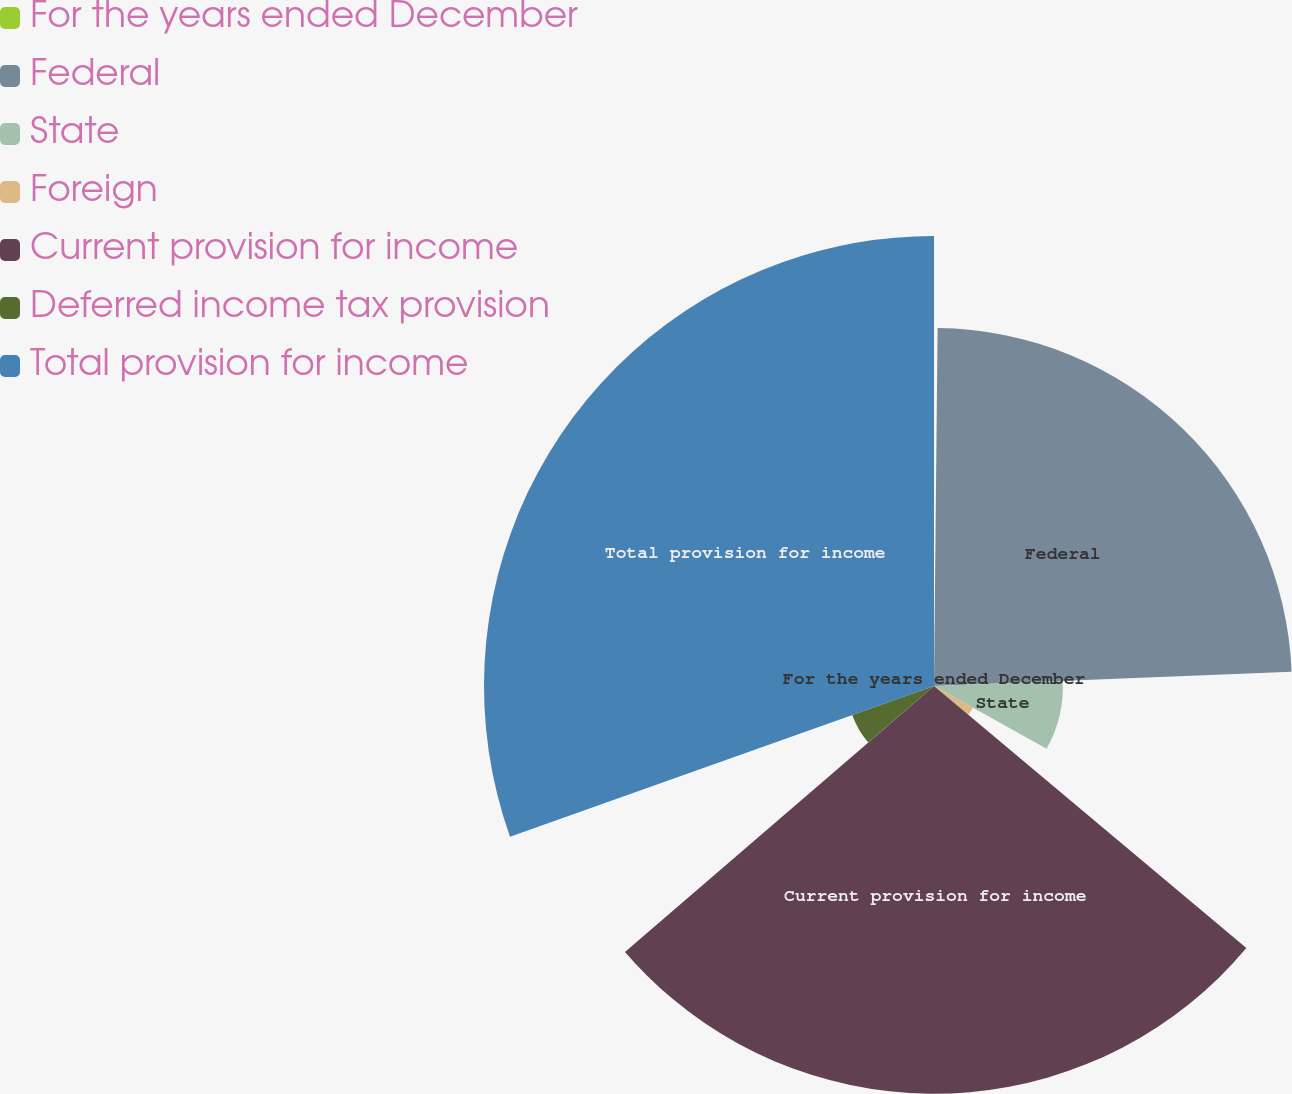Convert chart to OTSL. <chart><loc_0><loc_0><loc_500><loc_500><pie_chart><fcel>For the years ended December<fcel>Federal<fcel>State<fcel>Foreign<fcel>Current provision for income<fcel>Deferred income tax provision<fcel>Total provision for income<nl><fcel>0.16%<fcel>24.21%<fcel>8.72%<fcel>3.02%<fcel>27.58%<fcel>5.87%<fcel>30.44%<nl></chart> 